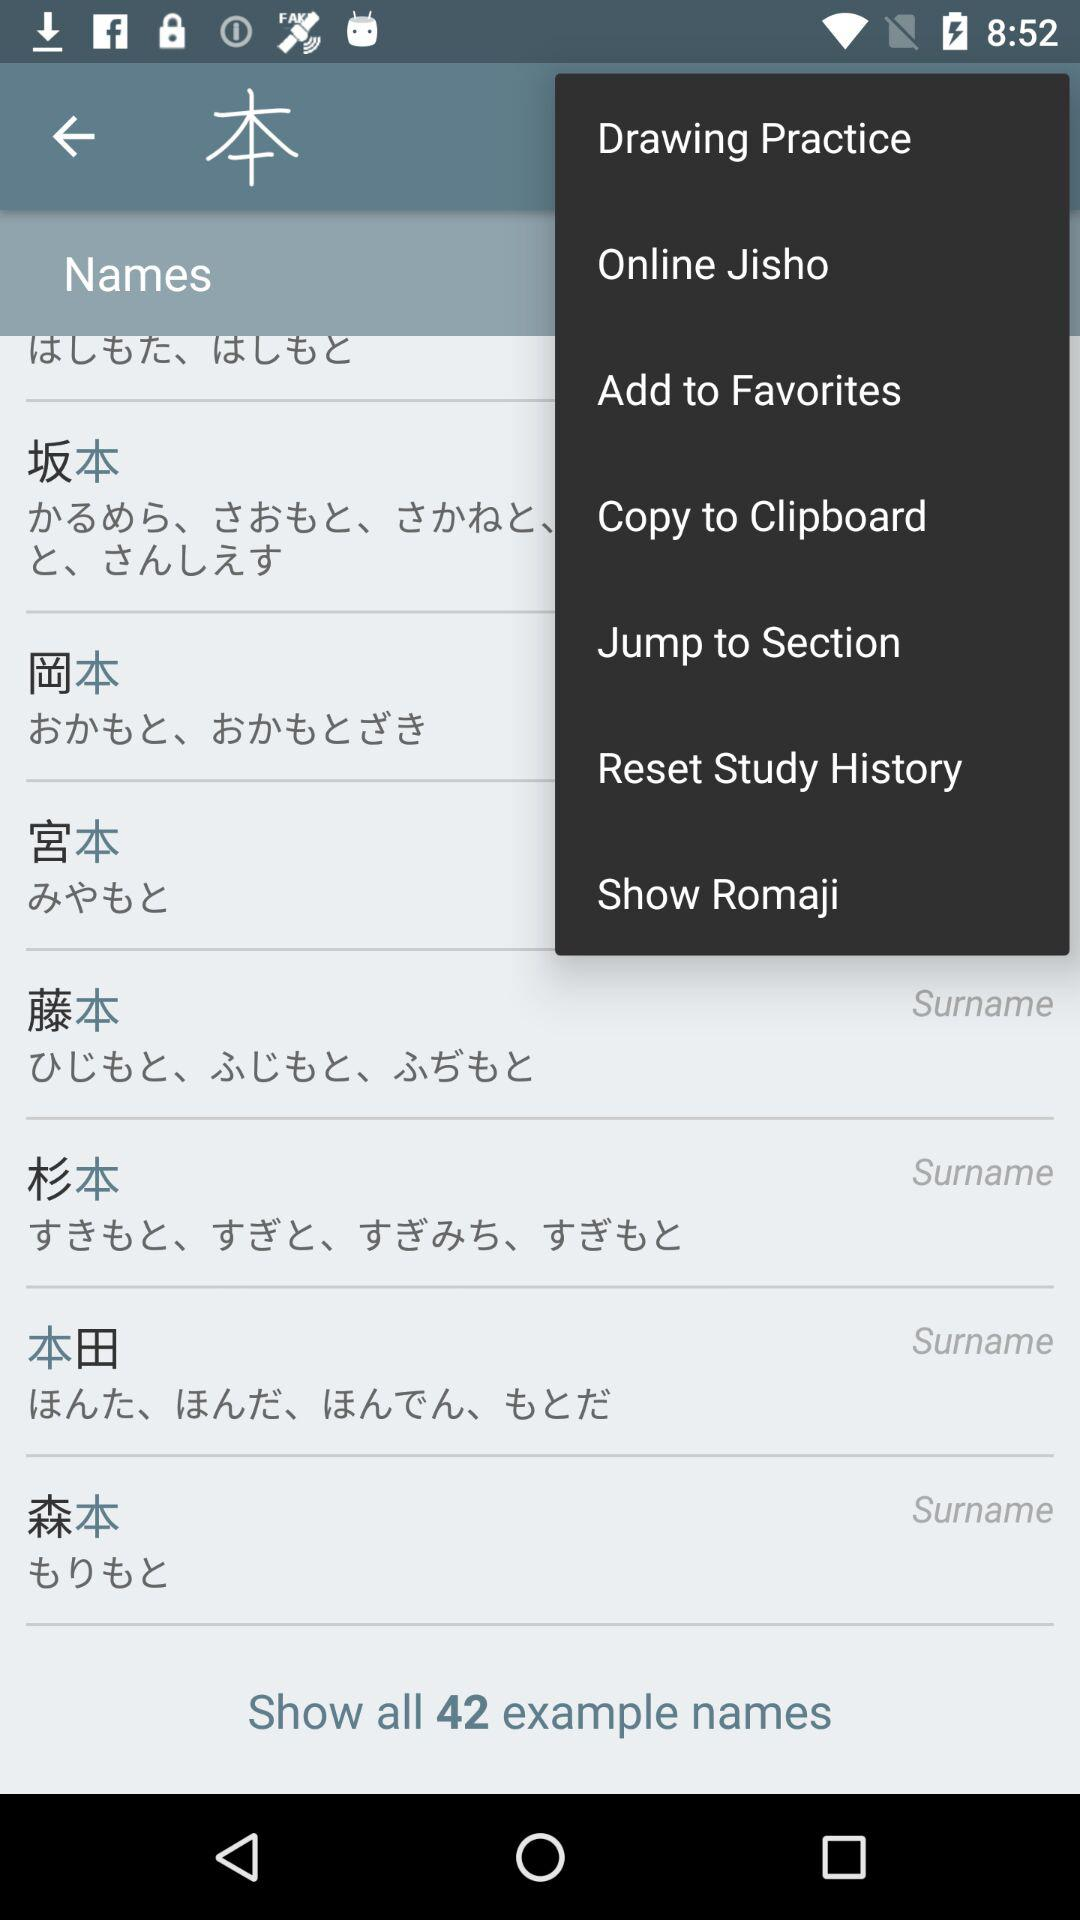How many example names are shown?
Answer the question using a single word or phrase. 42 